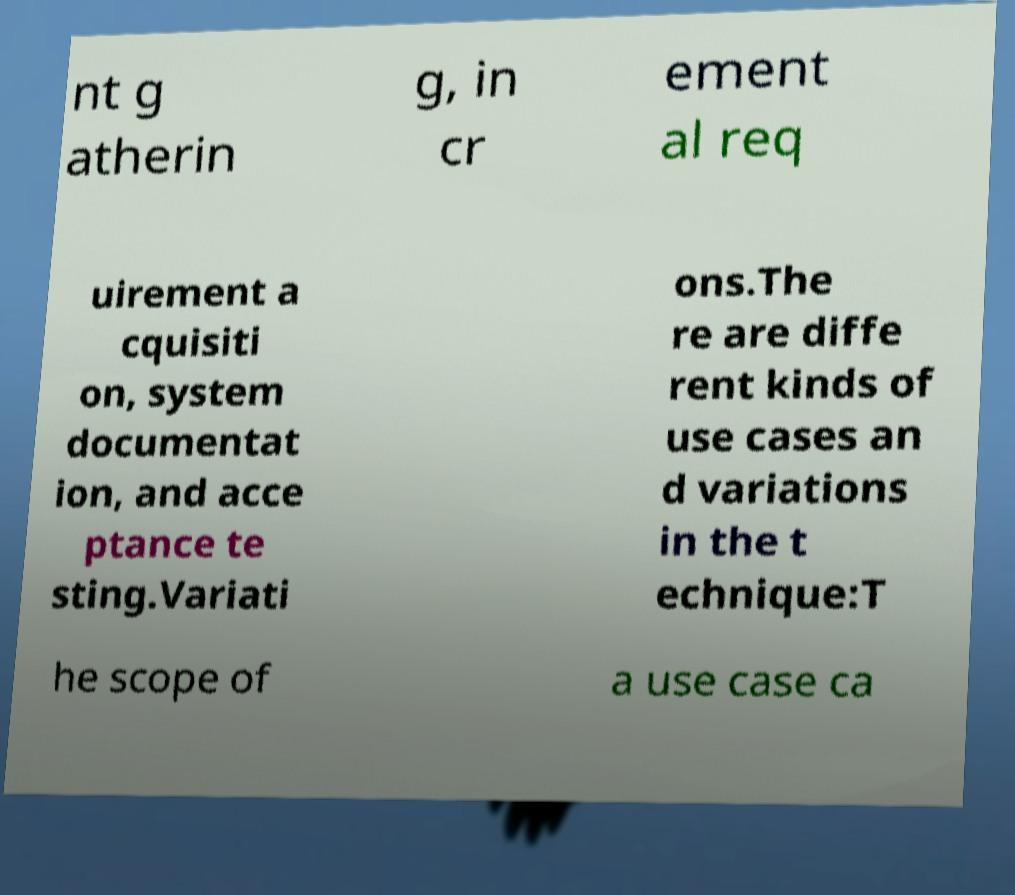Can you accurately transcribe the text from the provided image for me? nt g atherin g, in cr ement al req uirement a cquisiti on, system documentat ion, and acce ptance te sting.Variati ons.The re are diffe rent kinds of use cases an d variations in the t echnique:T he scope of a use case ca 